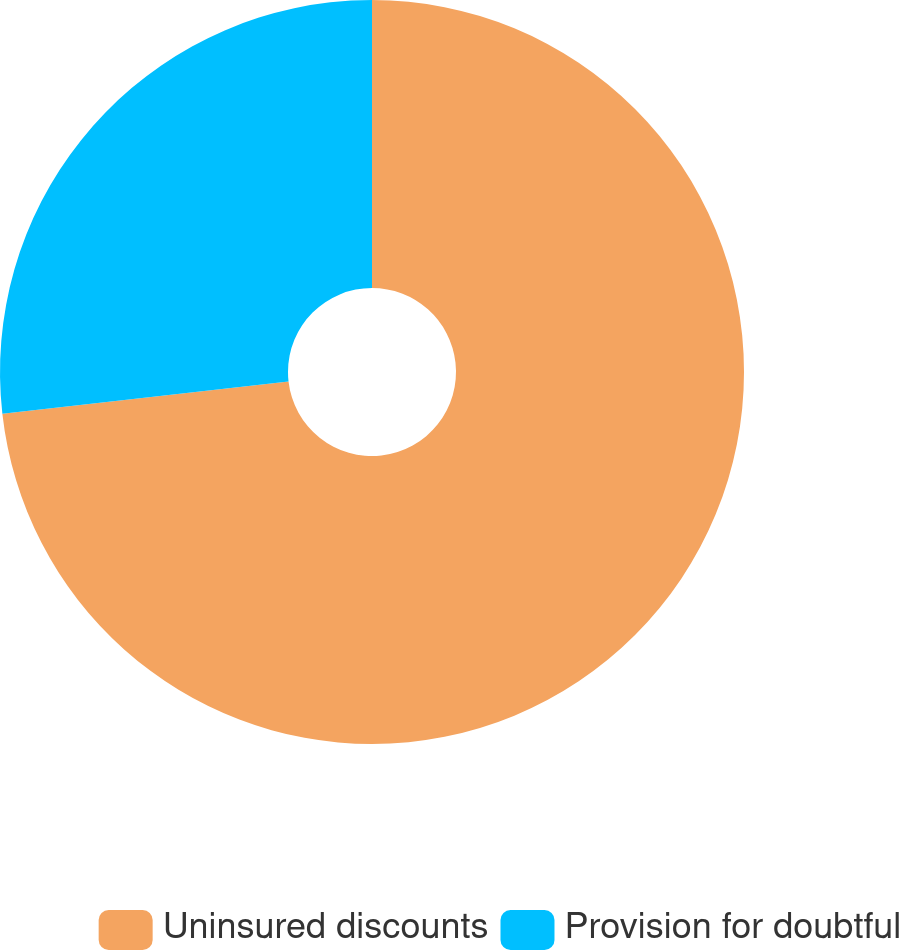Convert chart to OTSL. <chart><loc_0><loc_0><loc_500><loc_500><pie_chart><fcel>Uninsured discounts<fcel>Provision for doubtful<nl><fcel>73.21%<fcel>26.79%<nl></chart> 